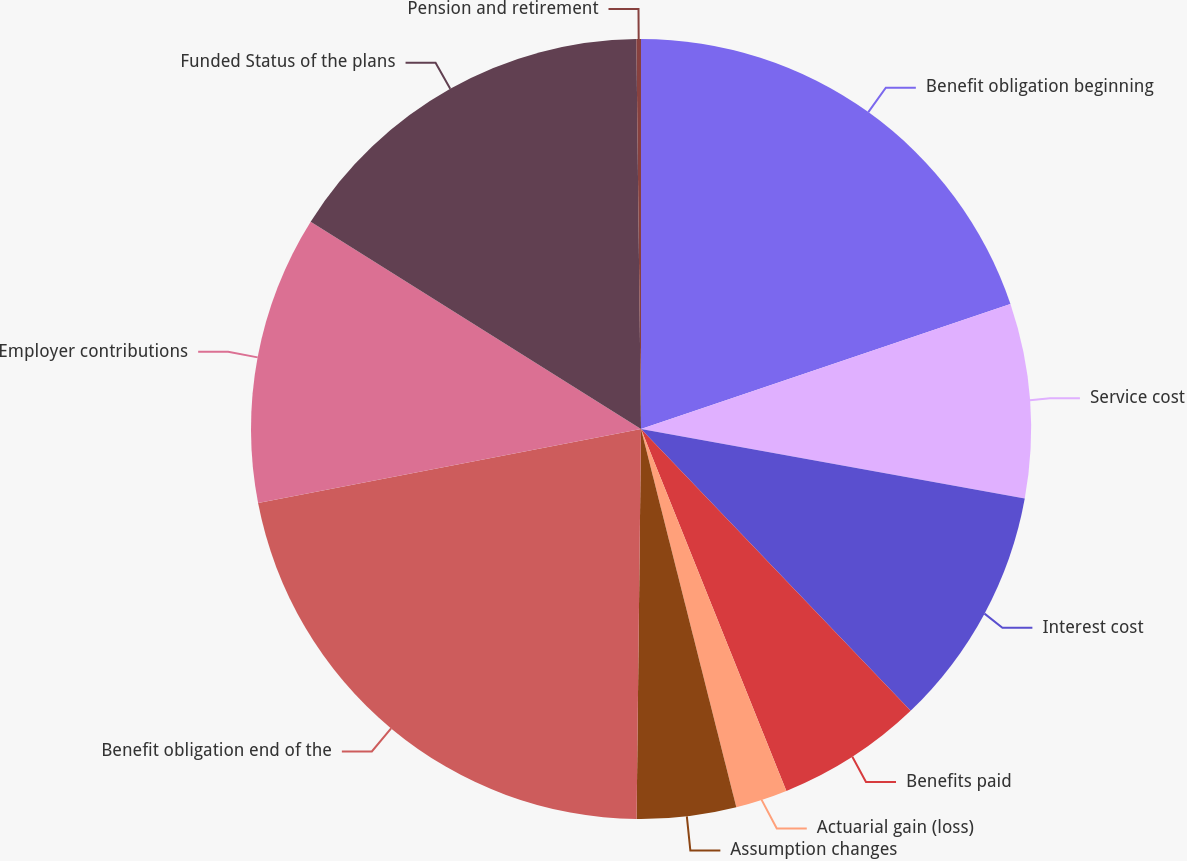Convert chart. <chart><loc_0><loc_0><loc_500><loc_500><pie_chart><fcel>Benefit obligation beginning<fcel>Service cost<fcel>Interest cost<fcel>Benefits paid<fcel>Actuarial gain (loss)<fcel>Assumption changes<fcel>Benefit obligation end of the<fcel>Employer contributions<fcel>Funded Status of the plans<fcel>Pension and retirement<nl><fcel>19.81%<fcel>8.04%<fcel>10.0%<fcel>6.07%<fcel>2.15%<fcel>4.11%<fcel>21.78%<fcel>11.96%<fcel>15.89%<fcel>0.19%<nl></chart> 